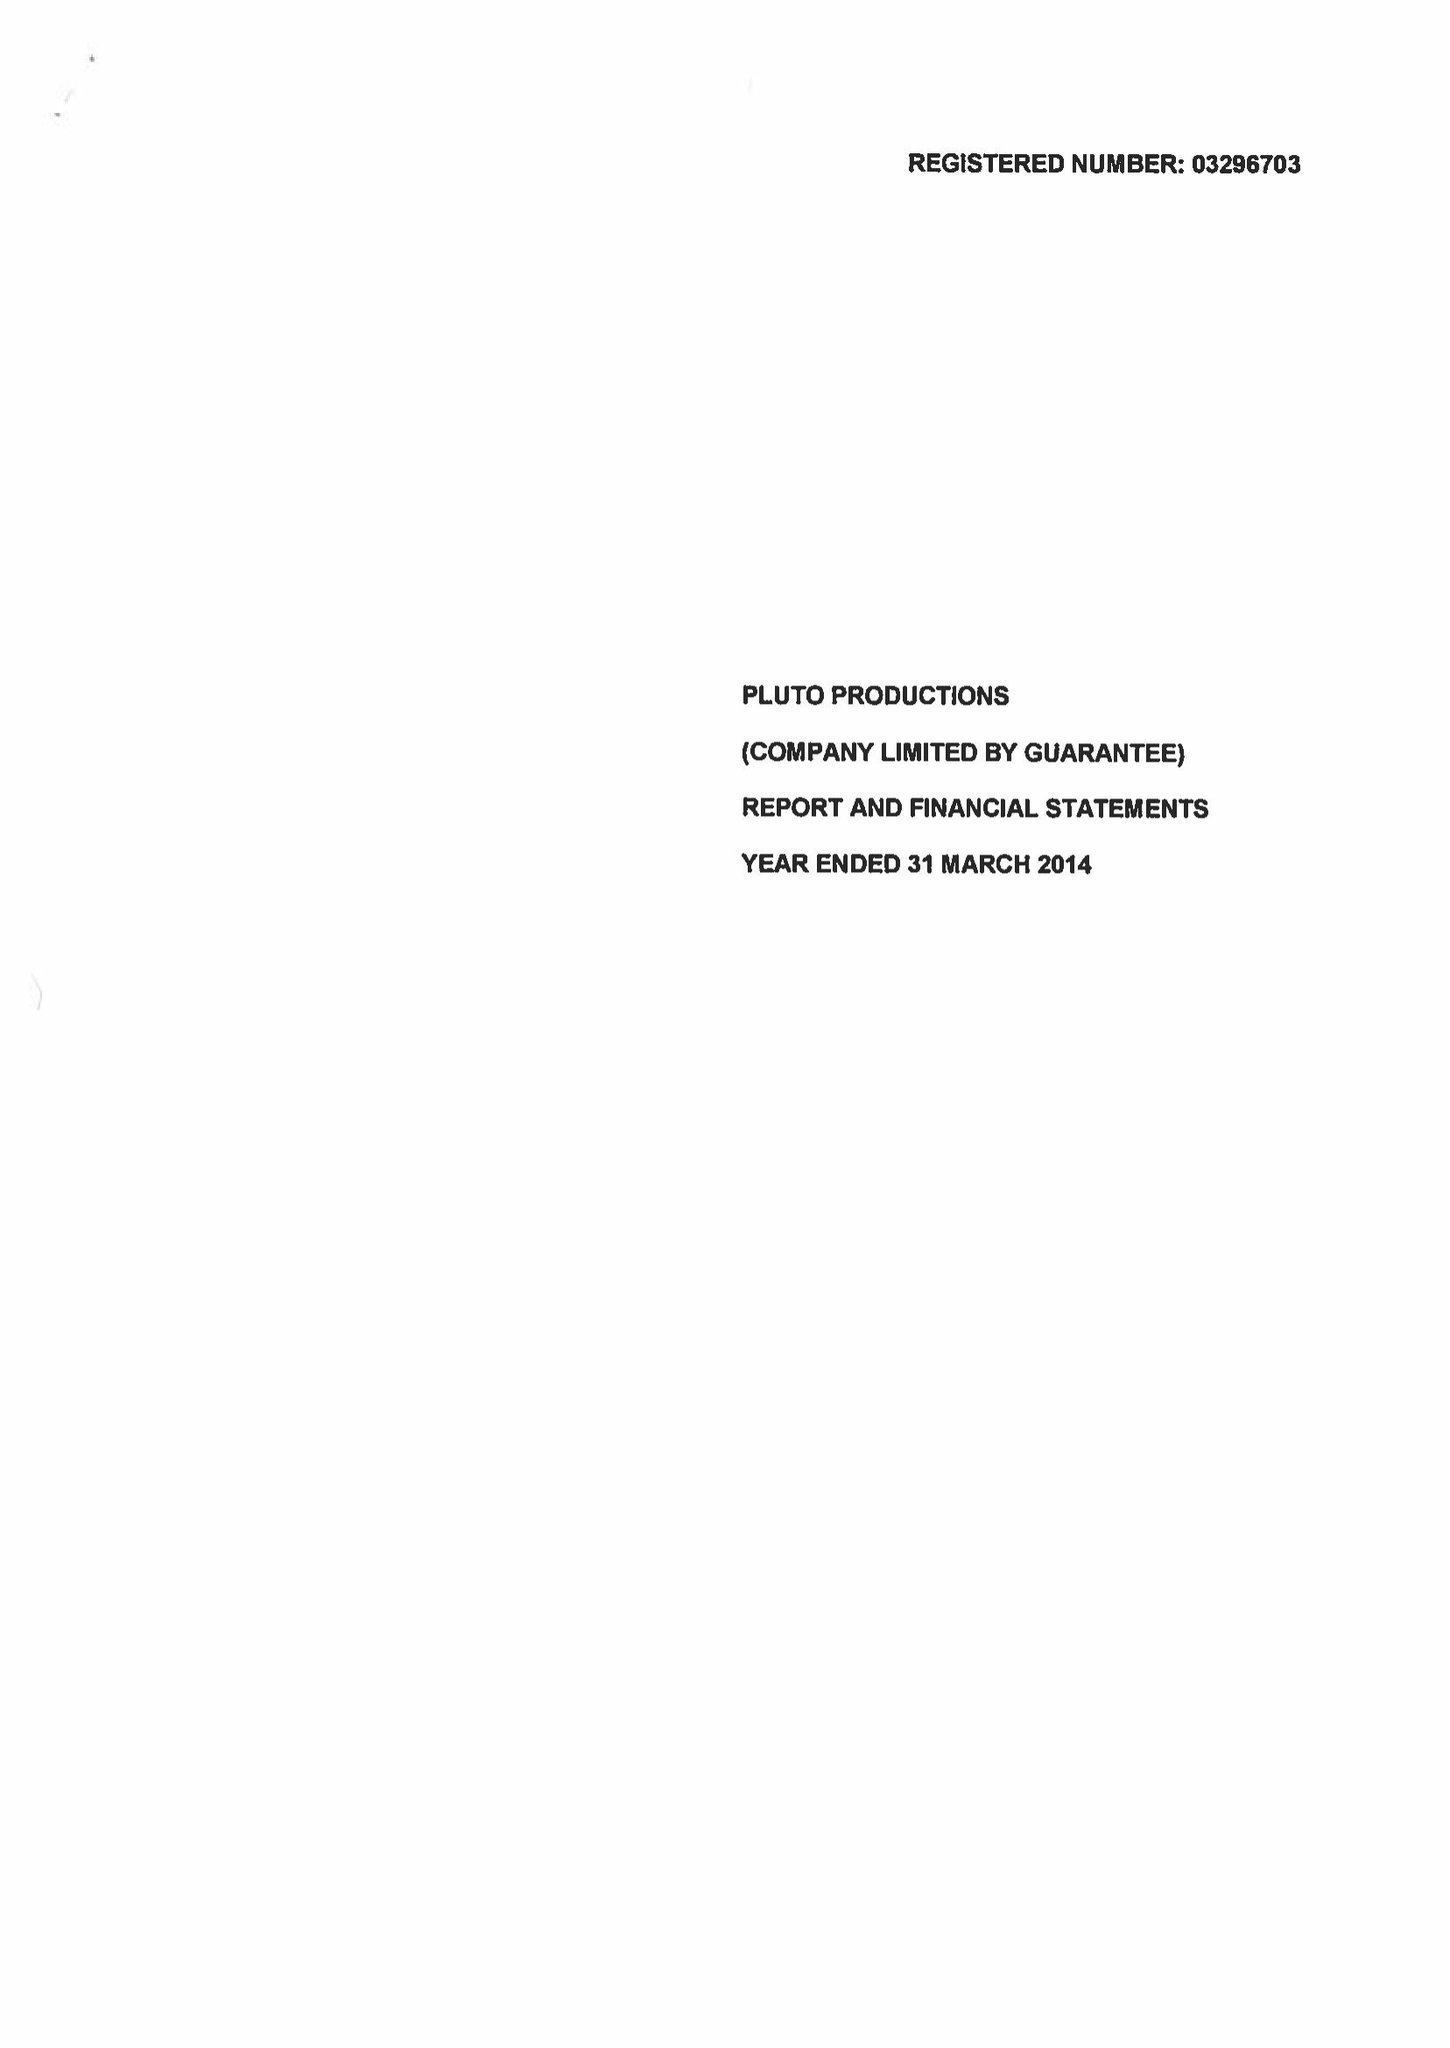What is the value for the address__street_line?
Answer the question using a single word or phrase. EDUCATION ROAD 